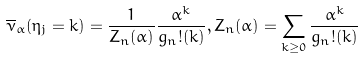Convert formula to latex. <formula><loc_0><loc_0><loc_500><loc_500>\overline { \nu } _ { \alpha } ( \eta _ { j } = k ) = \frac { 1 } { Z _ { n } ( \alpha ) } \frac { \alpha ^ { k } } { g _ { n } ! ( k ) } , Z _ { n } ( \alpha ) = \sum _ { k \geq 0 } \frac { \alpha ^ { k } } { g _ { n } ! ( k ) }</formula> 